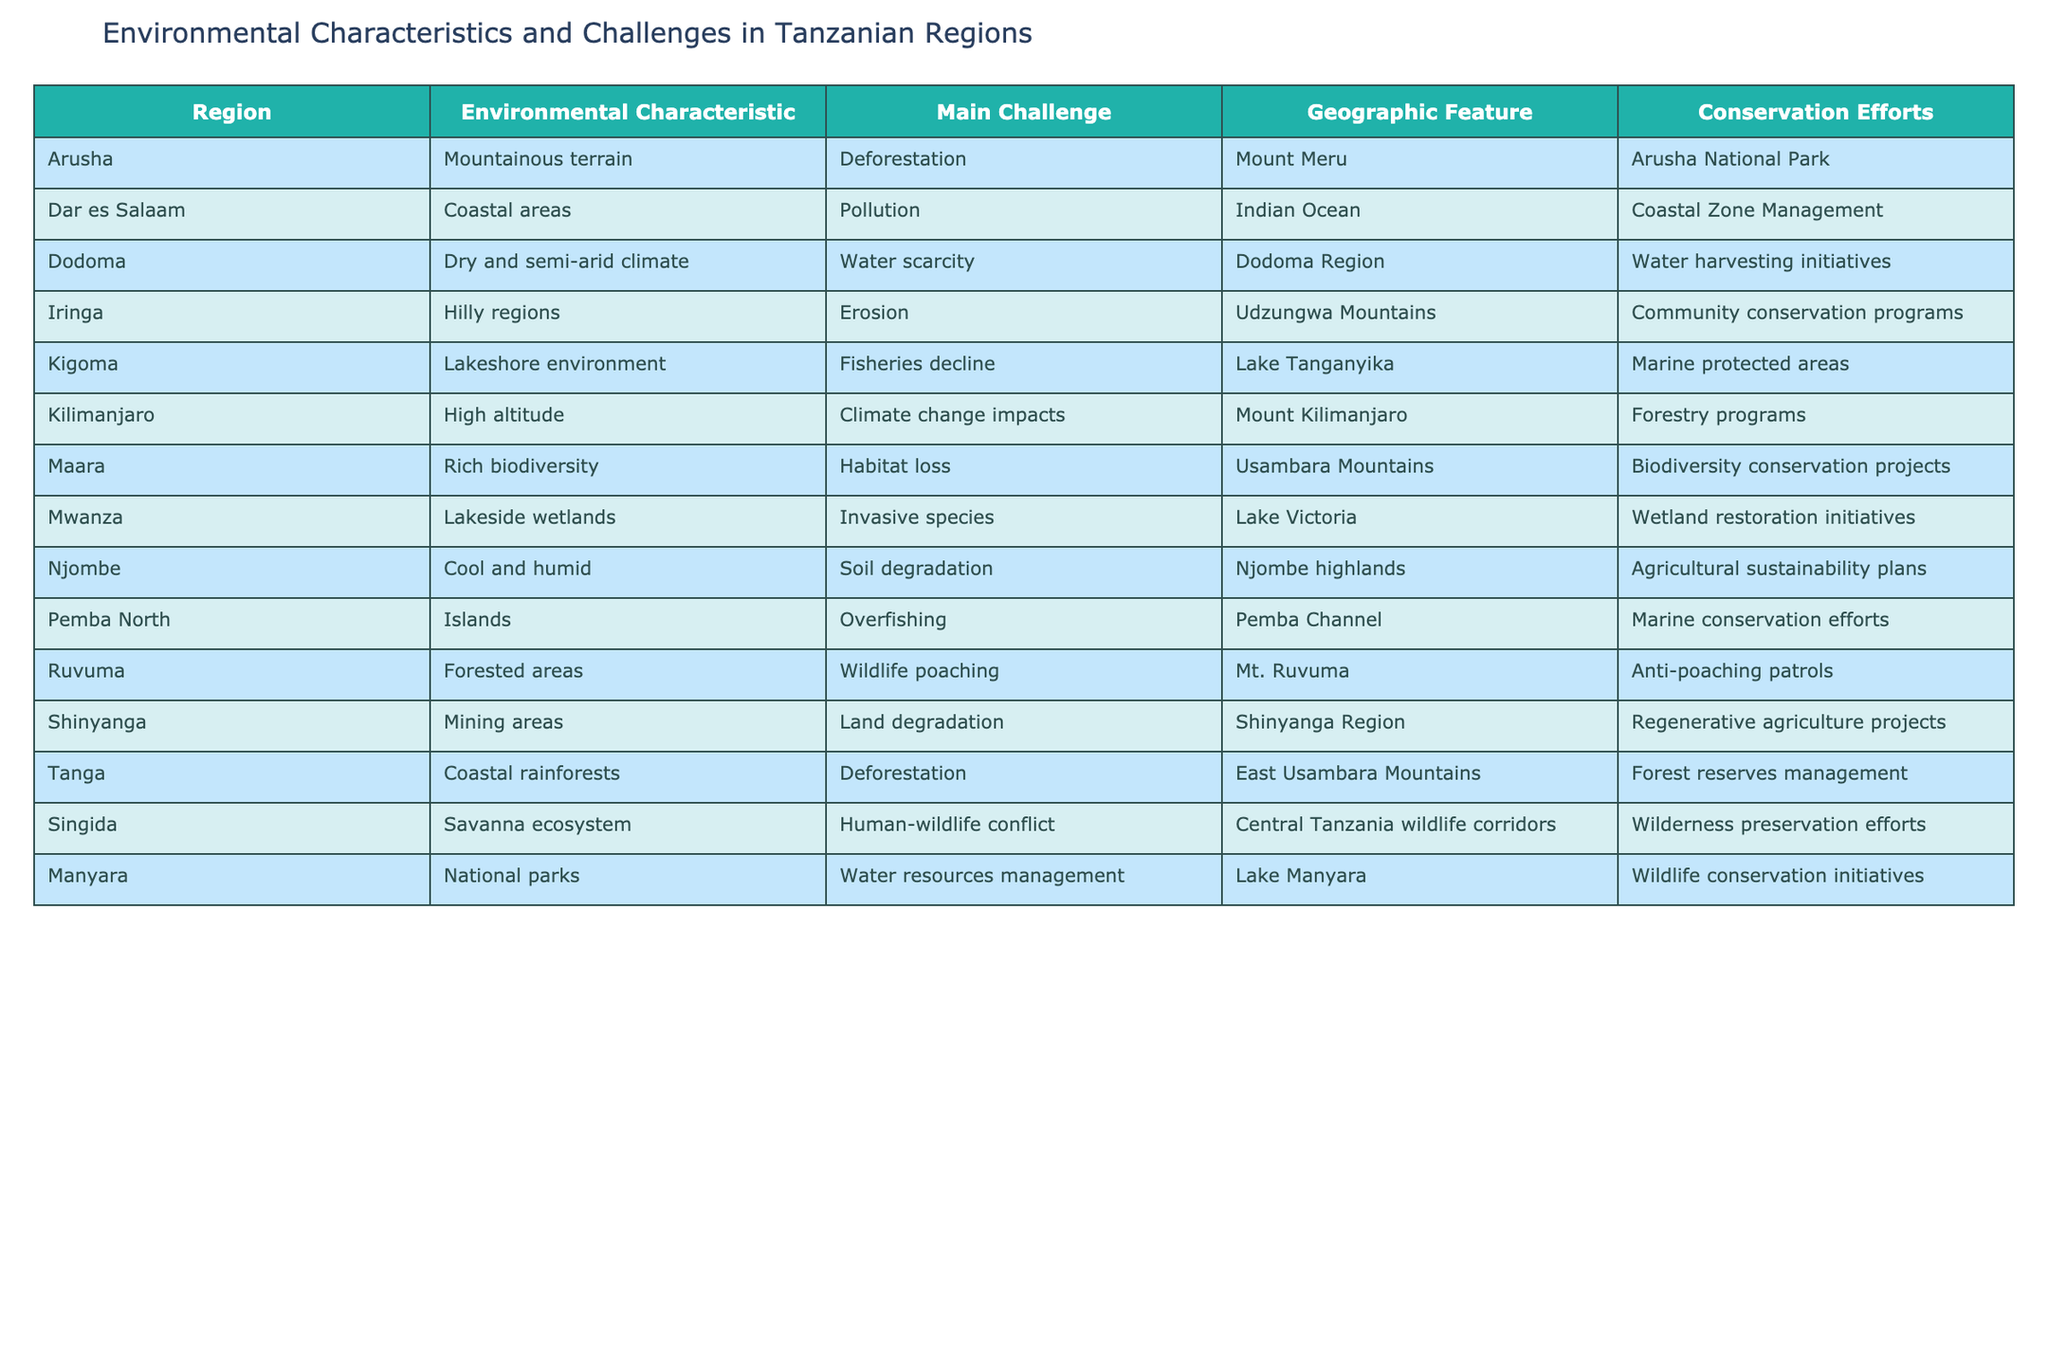What is the main challenge faced by the Kigoma region? The table indicates that the main challenge in the Kigoma region is fisheries decline. This information can be found directly in the row corresponding to Kigoma in the table.
Answer: Fisheries decline Which region has a hilly geographic feature? According to the table, the Iringa region is noted for its hilly regions as the geographic feature. This is retrieved from the specific information related to Iringa in the table.
Answer: Iringa How many regions face deforestation as a main challenge? By reviewing the table, we can see that both Arusha and Tanga have "Deforestation" listed as their main challenge. Hence, adding them up results in a total of 2 regions facing deforestation.
Answer: 2 Is it true that water scarcity is an issue in the Dodoma region? The table shows that the main challenge in Dodoma is water scarcity. Therefore, the statement is true as it aligns with the information from the table.
Answer: Yes Which region has the highest altitude environmental characteristic? The Kilimanjaro region is the one identified as having high altitude as its environmental characteristic. This is confirmed directly in the table under the Kilimanjaro row.
Answer: Kilimanjaro What is the average number of conservation efforts mentioned for regions facing a main challenge? There are 13 regions listed; counting specific conservation efforts, we find Arusha, Dar es Salaam, Dodoma, Iringa, Kigoma, Kilimanjaro, Maara, Mwanza, Njombe, Pemba North, Ruvuma, Shinyanga, Tanga, and Singida, totaling 13 conservation efforts. The average, therefore, is 1 effort per region as there is one effort listed for each.
Answer: 1 In which region is soil degradation an environmental challenge? The table shows that the main challenge regarding environmental degradation in the Njombe region is soil degradation. This is found in the Njombe row of the table.
Answer: Njombe What are the two main challenges faced by regions with coastal geographic features? Observing both the Dar es Salaam and Tanga regions, we find that they face pollution and deforestation, respectively. This analysis is done by checking the main challenges in those specific rows.
Answer: Pollution and deforestation 